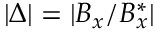Convert formula to latex. <formula><loc_0><loc_0><loc_500><loc_500>| \Delta | = | B _ { x } / B _ { x } ^ { * } |</formula> 